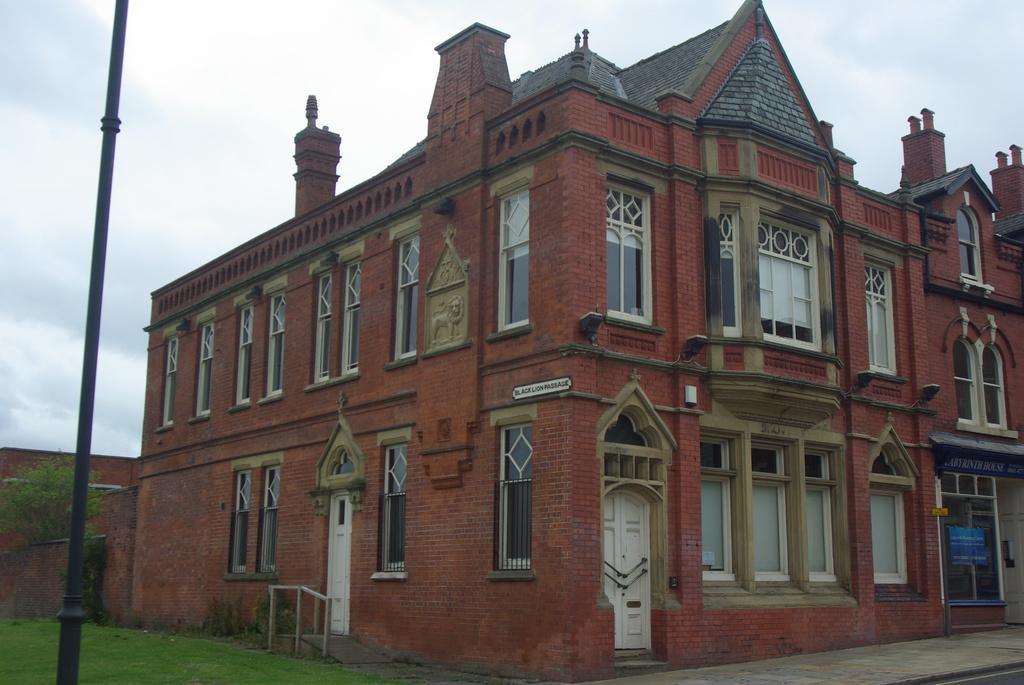How would you summarize this image in a sentence or two? In this image I see a building on which there are windows and doors and I see the green grass and I see a black pole over here and I see the plants over here and I see the path over here. In the background I see the sky. 